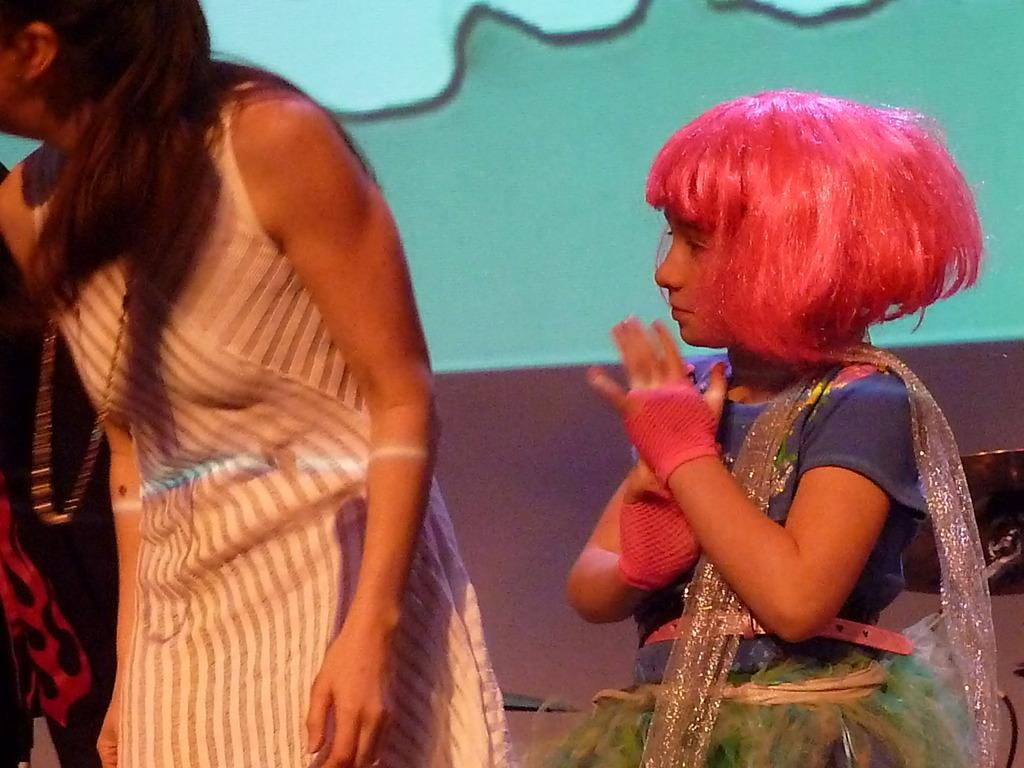Who are the people in the image? There is a girl and a lady in the image. What can be seen in the background of the image? There is a wall in the background of the image. What type of transport is the toad using to travel in the image? There is no toad present in the image, so it is not possible to determine what type of transport it might be using. 